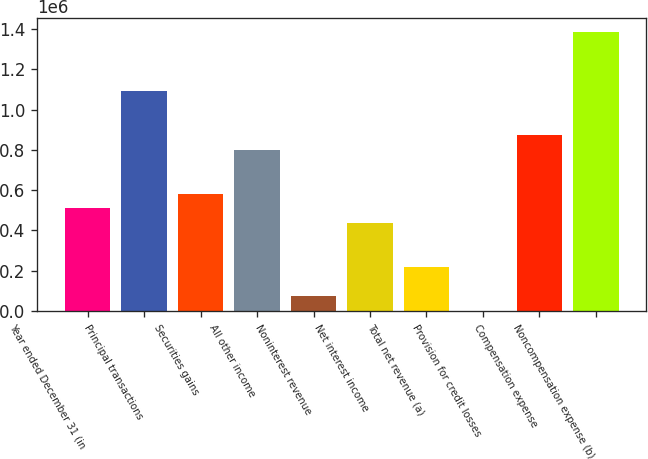Convert chart. <chart><loc_0><loc_0><loc_500><loc_500><bar_chart><fcel>Year ended December 31 (in<fcel>Principal transactions<fcel>Securities gains<fcel>All other income<fcel>Noninterest revenue<fcel>Net interest income<fcel>Total net revenue (a)<fcel>Provision for credit losses<fcel>Compensation expense<fcel>Noncompensation expense (b)<nl><fcel>510259<fcel>1.09337e+06<fcel>583147<fcel>801814<fcel>72925.8<fcel>437370<fcel>218703<fcel>37<fcel>874703<fcel>1.38492e+06<nl></chart> 